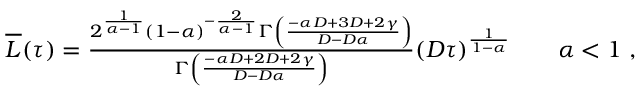<formula> <loc_0><loc_0><loc_500><loc_500>\begin{array} { r } { \overline { L } ( \tau ) = \frac { 2 ^ { \frac { 1 } { \alpha - 1 } } ( 1 - \alpha ) ^ { - \frac { 2 } { \alpha - 1 } } \Gamma \left ( \frac { - \alpha D + 3 D + 2 \gamma } { D - D \alpha } \right ) } { \Gamma \left ( \frac { - \alpha D + 2 D + 2 \gamma } { D - D \alpha } \right ) } ( D \tau ) ^ { \frac { 1 } { 1 - \alpha } } \quad \alpha < 1 \ , } \end{array}</formula> 